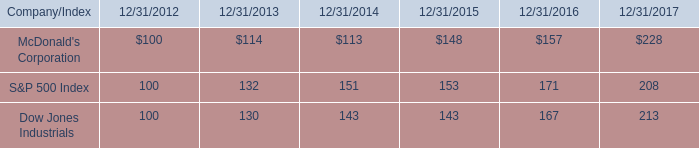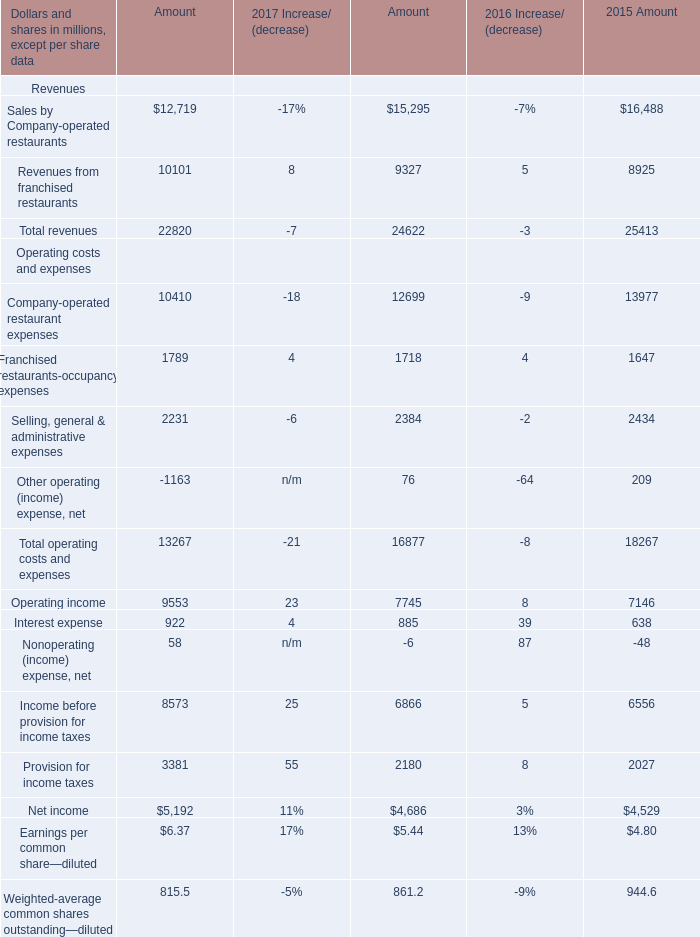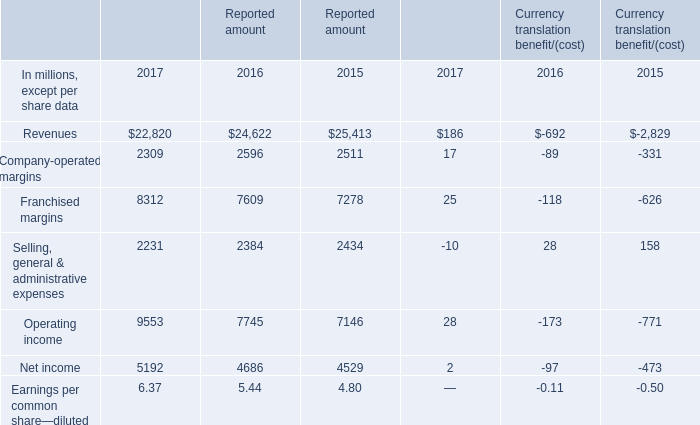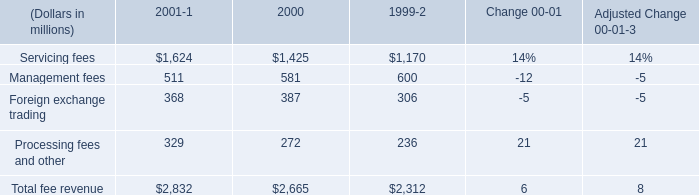What is the total value of Revenues, Company-operated margins, Franchised margins and Selling, general & administrative expenses in 2017 ? (in million) 
Computations: (((((((22820 + 2309) + 8312) + 2231) + 186) + 17) + 25) - 10)
Answer: 35890.0. 